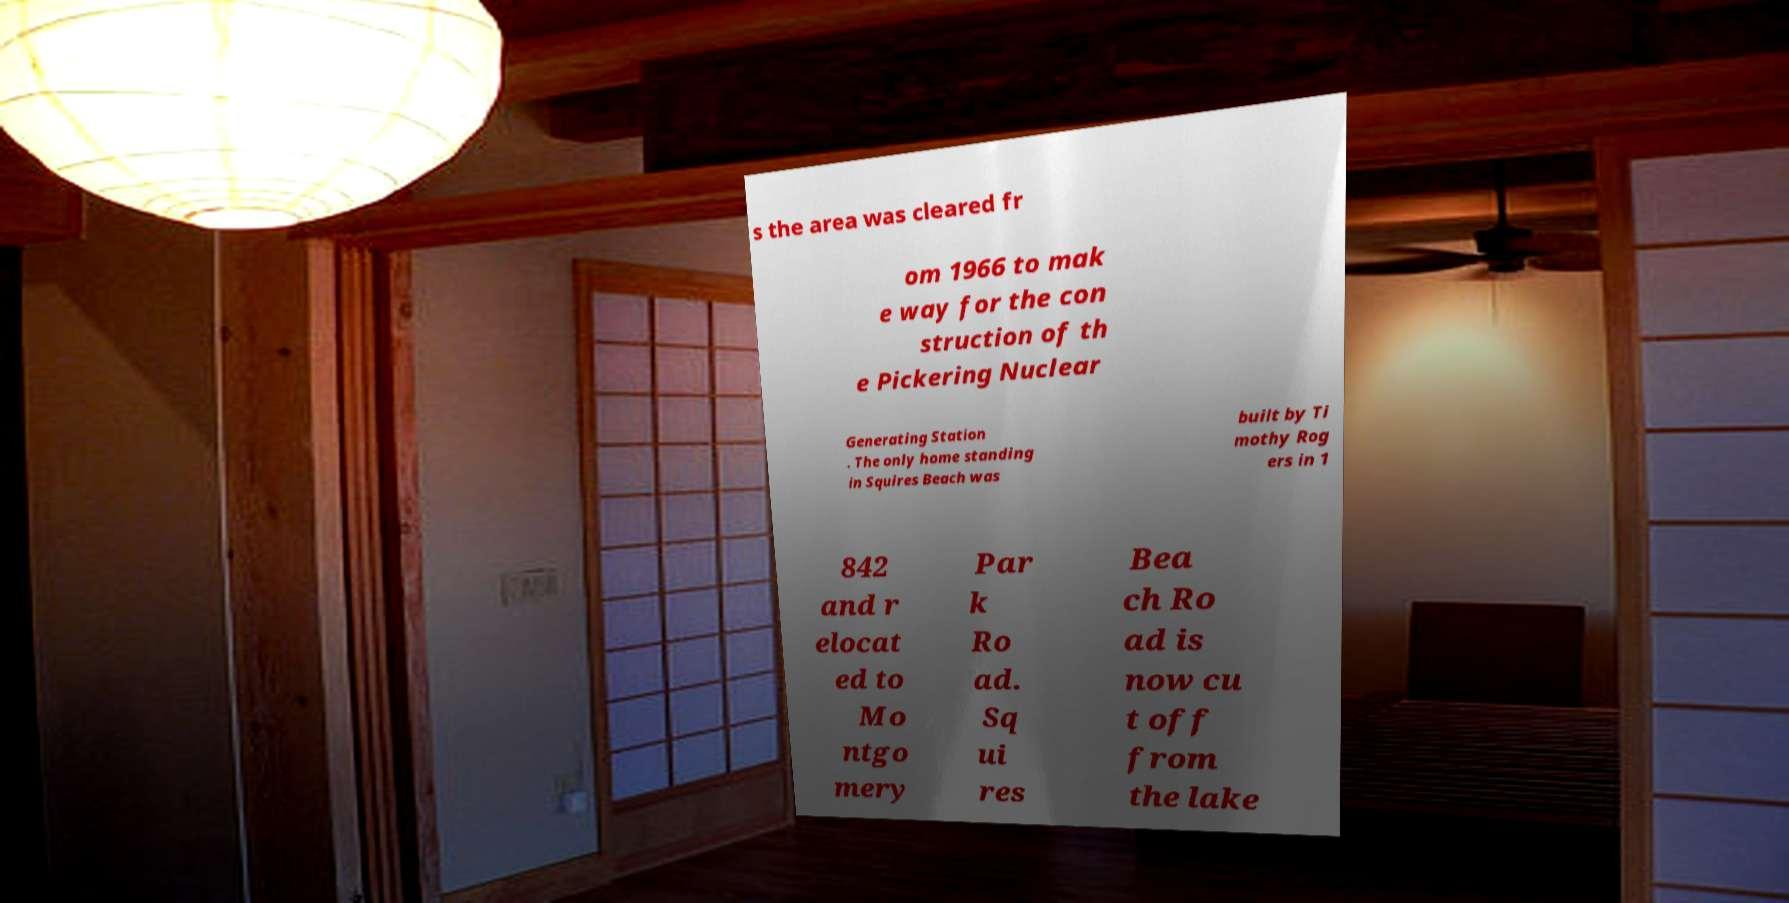Can you read and provide the text displayed in the image?This photo seems to have some interesting text. Can you extract and type it out for me? s the area was cleared fr om 1966 to mak e way for the con struction of th e Pickering Nuclear Generating Station . The only home standing in Squires Beach was built by Ti mothy Rog ers in 1 842 and r elocat ed to Mo ntgo mery Par k Ro ad. Sq ui res Bea ch Ro ad is now cu t off from the lake 